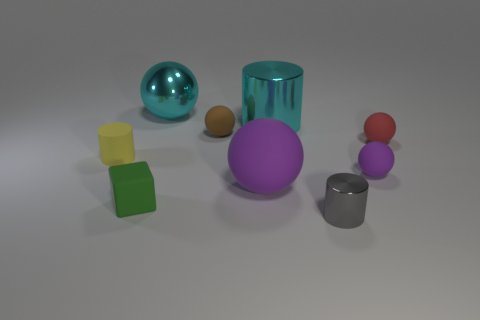Subtract all small cylinders. How many cylinders are left? 1 Add 1 small red matte things. How many objects exist? 10 Subtract all brown spheres. How many spheres are left? 4 Subtract all cylinders. How many objects are left? 6 Subtract all brown balls. Subtract all brown cubes. How many balls are left? 4 Subtract all red blocks. How many purple spheres are left? 2 Subtract all large yellow metal cylinders. Subtract all tiny brown objects. How many objects are left? 8 Add 4 small purple things. How many small purple things are left? 5 Add 1 yellow rubber things. How many yellow rubber things exist? 2 Subtract 0 gray balls. How many objects are left? 9 